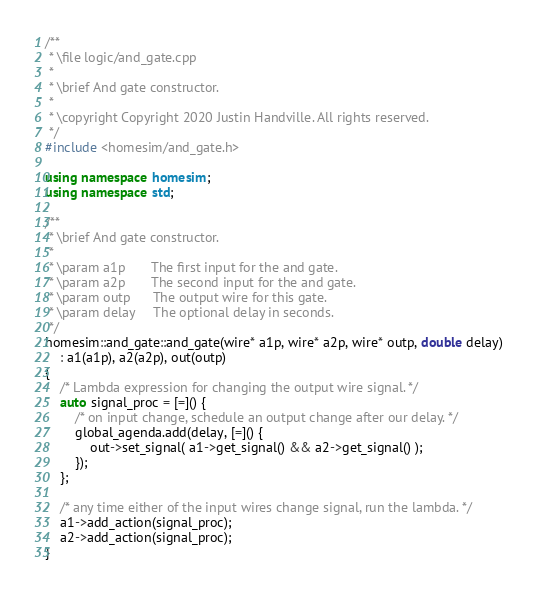Convert code to text. <code><loc_0><loc_0><loc_500><loc_500><_C++_>/**
 * \file logic/and_gate.cpp
 *
 * \brief And gate constructor.
 *
 * \copyright Copyright 2020 Justin Handville. All rights reserved.
 */
#include <homesim/and_gate.h>

using namespace homesim;
using namespace std;

/**
 * \brief And gate constructor.
 *
 * \param a1p       The first input for the and gate.
 * \param a2p       The second input for the and gate.
 * \param outp      The output wire for this gate.
 * \param delay     The optional delay in seconds.
 */
homesim::and_gate::and_gate(wire* a1p, wire* a2p, wire* outp, double delay)
    : a1(a1p), a2(a2p), out(outp)
{
    /* Lambda expression for changing the output wire signal. */
    auto signal_proc = [=]() {
        /* on input change, schedule an output change after our delay. */
        global_agenda.add(delay, [=]() {
            out->set_signal( a1->get_signal() && a2->get_signal() );
        });
    };

    /* any time either of the input wires change signal, run the lambda. */
    a1->add_action(signal_proc);
    a2->add_action(signal_proc);
}
</code> 